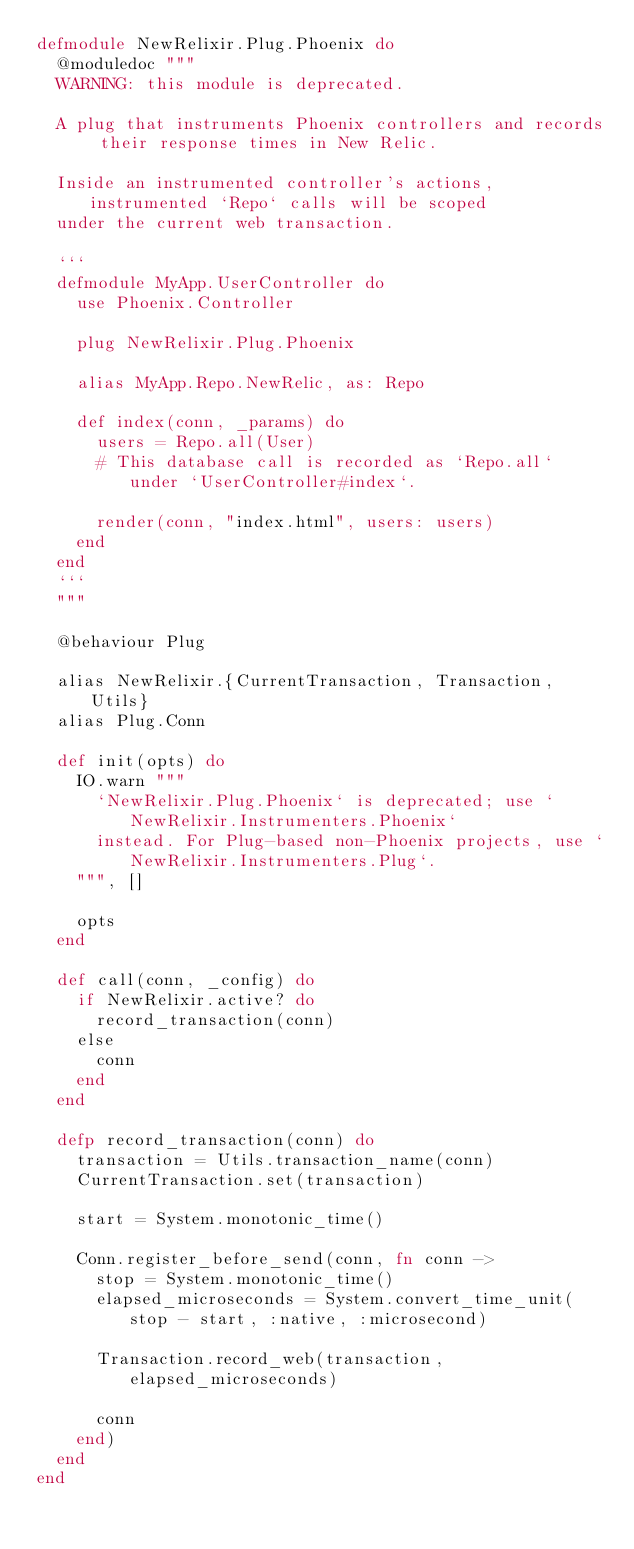<code> <loc_0><loc_0><loc_500><loc_500><_Elixir_>defmodule NewRelixir.Plug.Phoenix do
  @moduledoc """
  WARNING: this module is deprecated.

  A plug that instruments Phoenix controllers and records their response times in New Relic.

  Inside an instrumented controller's actions, instrumented `Repo` calls will be scoped
  under the current web transaction.

  ```
  defmodule MyApp.UserController do
    use Phoenix.Controller

    plug NewRelixir.Plug.Phoenix

    alias MyApp.Repo.NewRelic, as: Repo

    def index(conn, _params) do
      users = Repo.all(User)
      # This database call is recorded as `Repo.all` under `UserController#index`.

      render(conn, "index.html", users: users)
    end
  end
  ```
  """

  @behaviour Plug

  alias NewRelixir.{CurrentTransaction, Transaction, Utils}
  alias Plug.Conn

  def init(opts) do
    IO.warn """
      `NewRelixir.Plug.Phoenix` is deprecated; use `NewRelixir.Instrumenters.Phoenix`
      instead. For Plug-based non-Phoenix projects, use `NewRelixir.Instrumenters.Plug`.
    """, []

    opts
  end

  def call(conn, _config) do
    if NewRelixir.active? do
      record_transaction(conn)
    else
      conn
    end
  end

  defp record_transaction(conn) do
    transaction = Utils.transaction_name(conn)
    CurrentTransaction.set(transaction)

    start = System.monotonic_time()

    Conn.register_before_send(conn, fn conn ->
      stop = System.monotonic_time()
      elapsed_microseconds = System.convert_time_unit(stop - start, :native, :microsecond)

      Transaction.record_web(transaction, elapsed_microseconds)

      conn
    end)
  end
end
</code> 